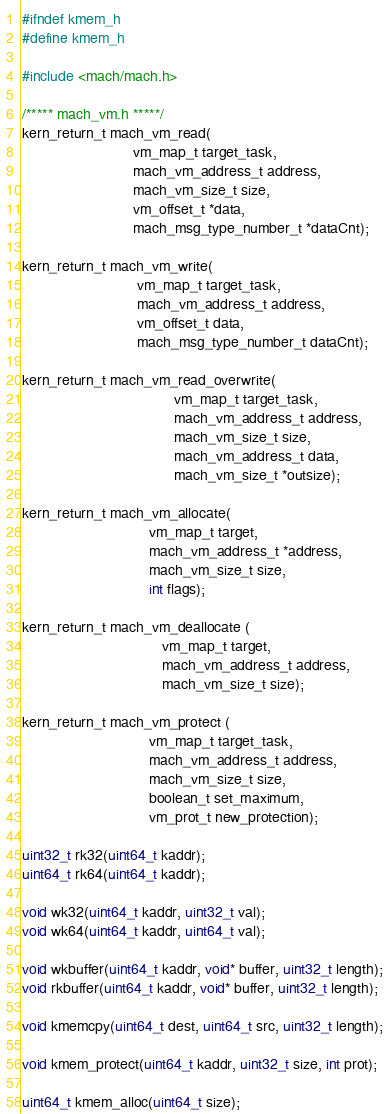<code> <loc_0><loc_0><loc_500><loc_500><_C_>#ifndef kmem_h
#define kmem_h

#include <mach/mach.h>

/***** mach_vm.h *****/
kern_return_t mach_vm_read(
                           vm_map_t target_task,
                           mach_vm_address_t address,
                           mach_vm_size_t size,
                           vm_offset_t *data,
                           mach_msg_type_number_t *dataCnt);

kern_return_t mach_vm_write(
                            vm_map_t target_task,
                            mach_vm_address_t address,
                            vm_offset_t data,
                            mach_msg_type_number_t dataCnt);

kern_return_t mach_vm_read_overwrite(
                                     vm_map_t target_task,
                                     mach_vm_address_t address,
                                     mach_vm_size_t size,
                                     mach_vm_address_t data,
                                     mach_vm_size_t *outsize);

kern_return_t mach_vm_allocate(
                               vm_map_t target,
                               mach_vm_address_t *address,
                               mach_vm_size_t size,
                               int flags);

kern_return_t mach_vm_deallocate (
                                  vm_map_t target,
                                  mach_vm_address_t address,
                                  mach_vm_size_t size);

kern_return_t mach_vm_protect (
                               vm_map_t target_task,
                               mach_vm_address_t address,
                               mach_vm_size_t size,
                               boolean_t set_maximum,
                               vm_prot_t new_protection);

uint32_t rk32(uint64_t kaddr);
uint64_t rk64(uint64_t kaddr);

void wk32(uint64_t kaddr, uint32_t val);
void wk64(uint64_t kaddr, uint64_t val);

void wkbuffer(uint64_t kaddr, void* buffer, uint32_t length);
void rkbuffer(uint64_t kaddr, void* buffer, uint32_t length);

void kmemcpy(uint64_t dest, uint64_t src, uint32_t length);

void kmem_protect(uint64_t kaddr, uint32_t size, int prot);

uint64_t kmem_alloc(uint64_t size);</code> 